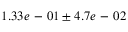<formula> <loc_0><loc_0><loc_500><loc_500>1 . 3 3 e - 0 1 \pm 4 . 7 e - 0 2</formula> 